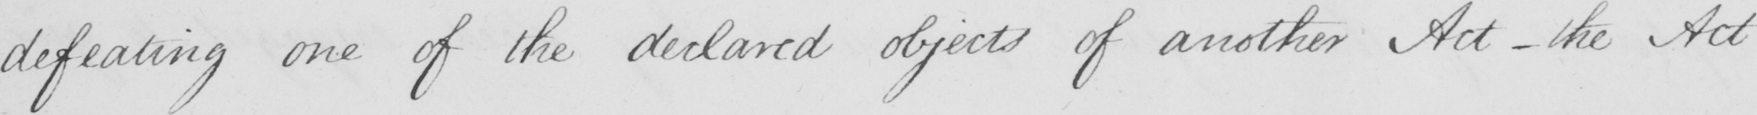Transcribe the text shown in this historical manuscript line. defeating one of the declared objects of another Act  _  the Act 